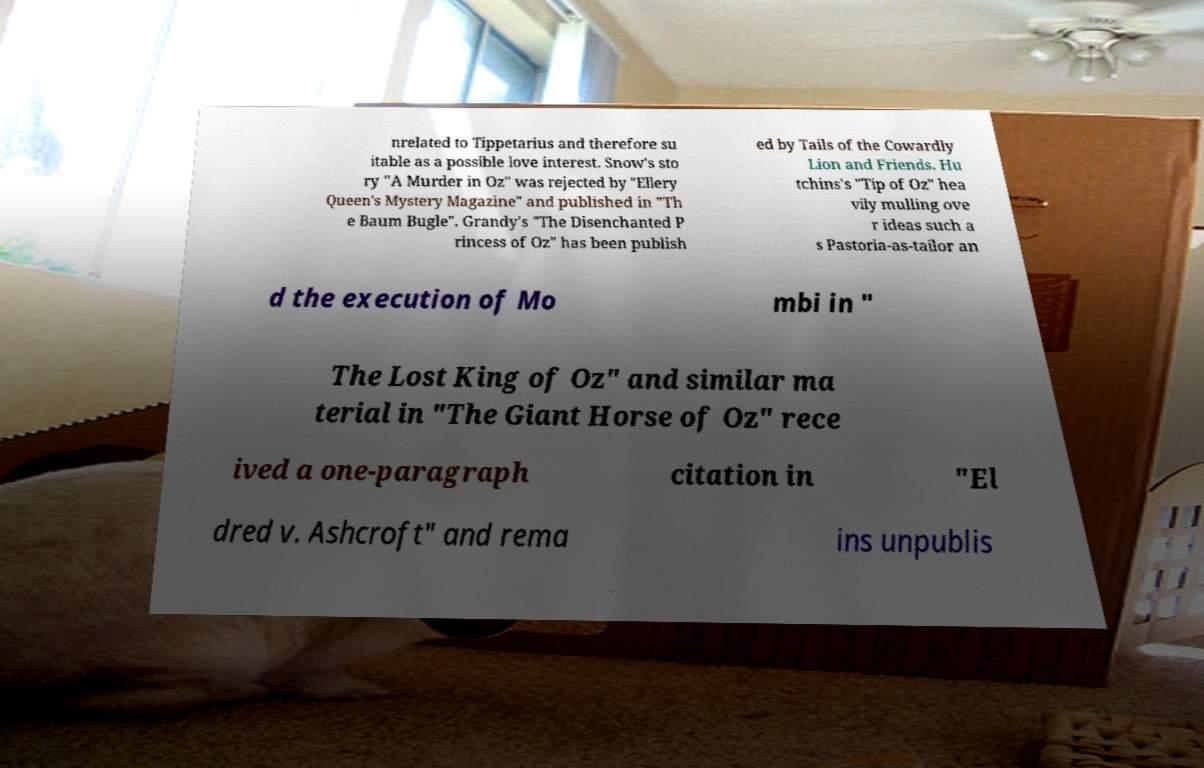Can you accurately transcribe the text from the provided image for me? nrelated to Tippetarius and therefore su itable as a possible love interest. Snow's sto ry "A Murder in Oz" was rejected by "Ellery Queen's Mystery Magazine" and published in "Th e Baum Bugle". Grandy's "The Disenchanted P rincess of Oz" has been publish ed by Tails of the Cowardly Lion and Friends. Hu tchins's "Tip of Oz" hea vily mulling ove r ideas such a s Pastoria-as-tailor an d the execution of Mo mbi in " The Lost King of Oz" and similar ma terial in "The Giant Horse of Oz" rece ived a one-paragraph citation in "El dred v. Ashcroft" and rema ins unpublis 